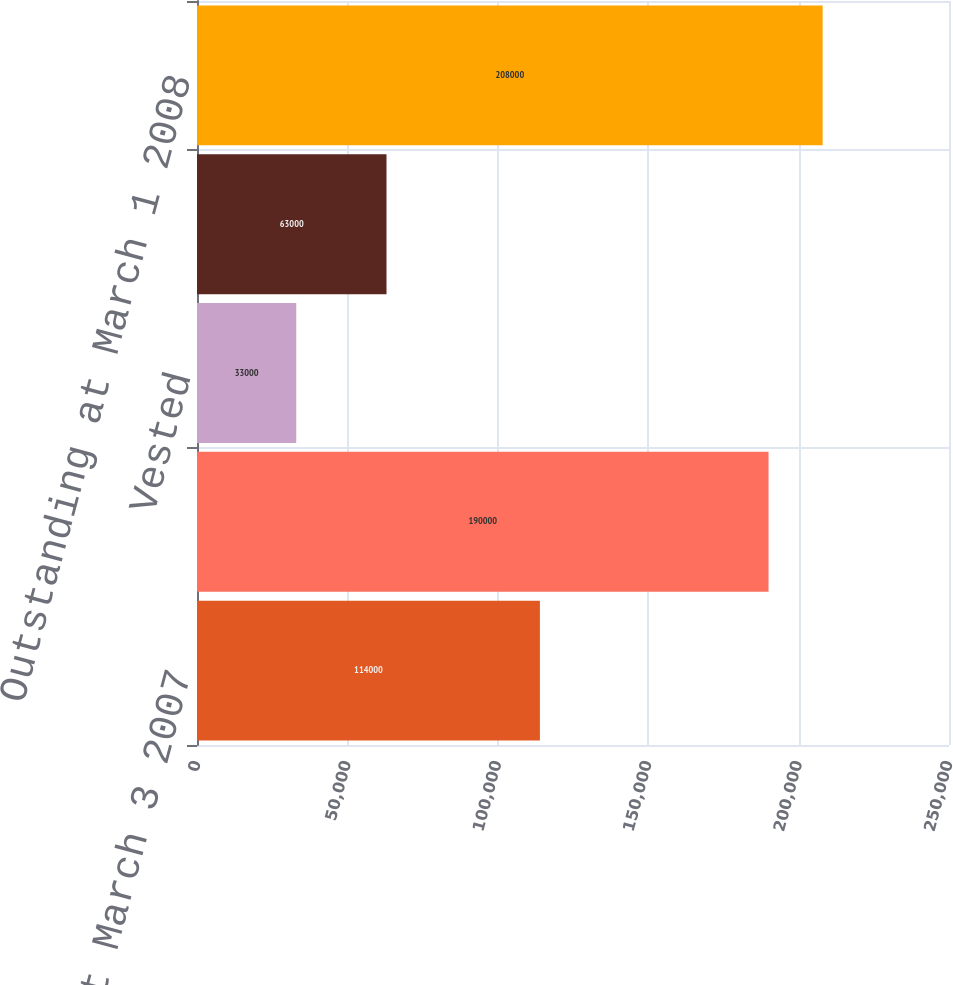<chart> <loc_0><loc_0><loc_500><loc_500><bar_chart><fcel>Outstanding at March 3 2007<fcel>Granted<fcel>Vested<fcel>Forfeited/Canceled<fcel>Outstanding at March 1 2008<nl><fcel>114000<fcel>190000<fcel>33000<fcel>63000<fcel>208000<nl></chart> 